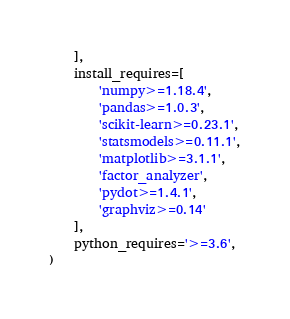Convert code to text. <code><loc_0><loc_0><loc_500><loc_500><_Python_>    ],
    install_requires=[
        'numpy>=1.18.4',
        'pandas>=1.0.3',
        'scikit-learn>=0.23.1',
        'statsmodels>=0.11.1',
        'matplotlib>=3.1.1',
        'factor_analyzer',
        'pydot>=1.4.1',
        'graphviz>=0.14'
    ],
    python_requires='>=3.6',
)
</code> 